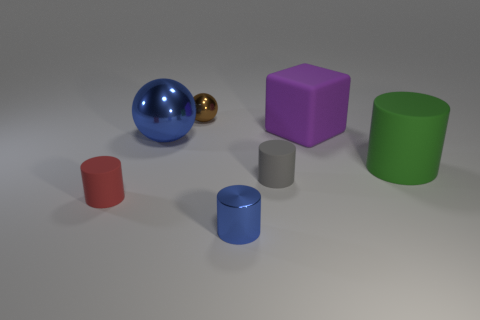Add 3 large yellow metal balls. How many objects exist? 10 Subtract all blocks. How many objects are left? 6 Add 5 green cylinders. How many green cylinders are left? 6 Add 4 small brown metallic spheres. How many small brown metallic spheres exist? 5 Subtract 0 red spheres. How many objects are left? 7 Subtract all big red metal cylinders. Subtract all small red objects. How many objects are left? 6 